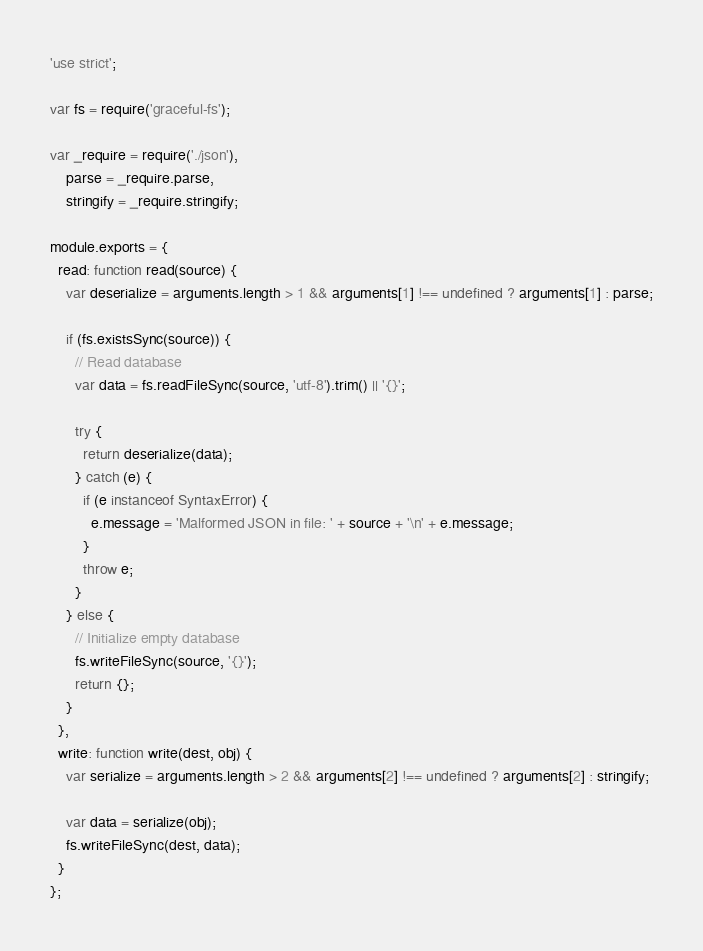Convert code to text. <code><loc_0><loc_0><loc_500><loc_500><_JavaScript_>'use strict';

var fs = require('graceful-fs');

var _require = require('./json'),
    parse = _require.parse,
    stringify = _require.stringify;

module.exports = {
  read: function read(source) {
    var deserialize = arguments.length > 1 && arguments[1] !== undefined ? arguments[1] : parse;

    if (fs.existsSync(source)) {
      // Read database
      var data = fs.readFileSync(source, 'utf-8').trim() || '{}';

      try {
        return deserialize(data);
      } catch (e) {
        if (e instanceof SyntaxError) {
          e.message = 'Malformed JSON in file: ' + source + '\n' + e.message;
        }
        throw e;
      }
    } else {
      // Initialize empty database
      fs.writeFileSync(source, '{}');
      return {};
    }
  },
  write: function write(dest, obj) {
    var serialize = arguments.length > 2 && arguments[2] !== undefined ? arguments[2] : stringify;

    var data = serialize(obj);
    fs.writeFileSync(dest, data);
  }
};</code> 